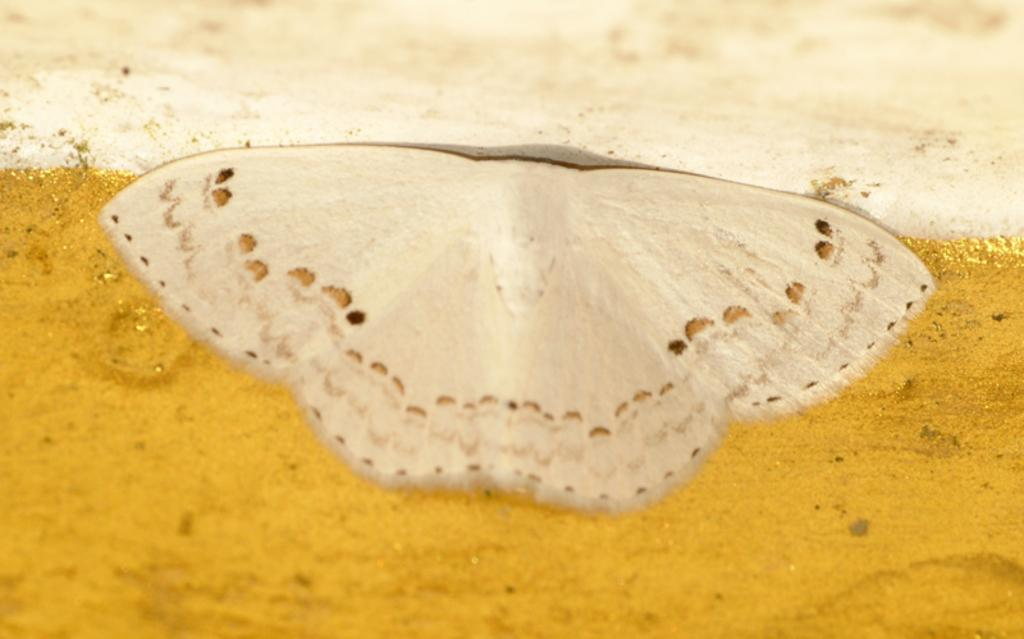What is the main subject of the image? There is a butterfly in the image. Where is the butterfly located? The butterfly is on a surface. What color is the surface the butterfly is on? The surface is golden yellow in color. What type of map is visible on the plate in the image? There is no map or plate present in the image; it features a butterfly on a golden yellow surface. 